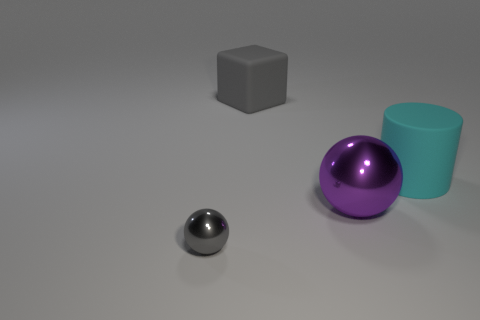Add 4 gray rubber things. How many objects exist? 8 Subtract all blocks. How many objects are left? 3 Subtract 0 blue spheres. How many objects are left? 4 Subtract all gray cubes. Subtract all big shiny things. How many objects are left? 2 Add 1 tiny things. How many tiny things are left? 2 Add 1 large cylinders. How many large cylinders exist? 2 